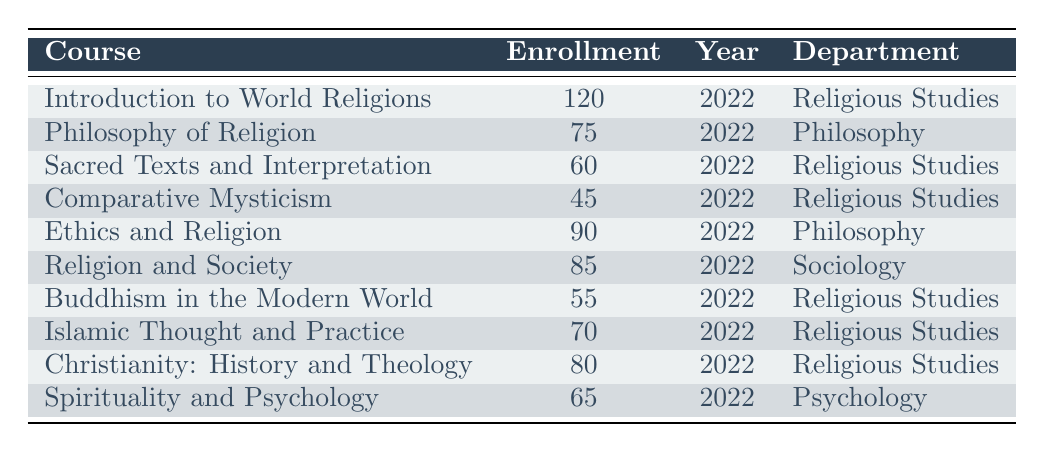What is the total enrollment in Religious Studies courses? The total enrollment for Religious Studies courses can be found by adding the enrollment numbers from the relevant rows: 120 (Introduction to World Religions) + 60 (Sacred Texts and Interpretation) + 45 (Comparative Mysticism) + 55 (Buddhism in the Modern World) + 70 (Islamic Thought and Practice) + 80 (Christianity: History and Theology) = 430.
Answer: 430 Which course has the highest enrollment? By looking at the enrollment column, the course with the highest enrollment is "Introduction to World Religions," which has 120 enrolled students.
Answer: Introduction to World Religions Is there a Philosophy course that has more than 80 students enrolled? There are two Philosophy courses in the table: "Philosophy of Religion" with 75 students and "Ethics and Religion" with 90 students. Since 90 is more than 80, the answer is yes.
Answer: Yes What is the average enrollment for Religious Studies courses? To calculate the average enrollment for Religious Studies, first sum the enrollments: 120 + 60 + 45 + 55 + 70 + 80 = 430. There are 6 courses, so the average is 430 / 6 = approximately 71.67.
Answer: 71.67 Is "Comparative Mysticism" the only course in the table with an enrollment less than 50? Looking at the enrollments, "Comparative Mysticism" has 45 students, which is indeed less than 50. However, checking all courses, there are none other than this that have enrollments below 50, confirming that it is the only one.
Answer: Yes What percentage of students are enrolled in "Philosophy of Religion" relative to the total enrollment of all courses? First, sum the enrollments of all courses to find the total: 120 + 75 + 60 + 45 + 90 + 85 + 55 + 70 + 80 + 65 = 775. "Philosophy of Religion" has 75 students, so the percentage is (75 / 775) * 100 = approximately 9.68%.
Answer: 9.68% Which department has the least number of total enrollments? To find the department with the least enrollment, sum the enrollments for each department: Religious Studies = 430, Philosophy = 165, Sociology = 85, and Psychology = 65. The department with the least number of enrollments is Psychology with 65.
Answer: Psychology How many courses related to Buddhism have an enrollment greater than 50? The courses related to Buddhism are "Buddhism in the Modern World" (55) and it is the only one with an enrollment greater than 50.
Answer: 1 